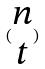<formula> <loc_0><loc_0><loc_500><loc_500>( \begin{matrix} n \\ t \end{matrix} )</formula> 